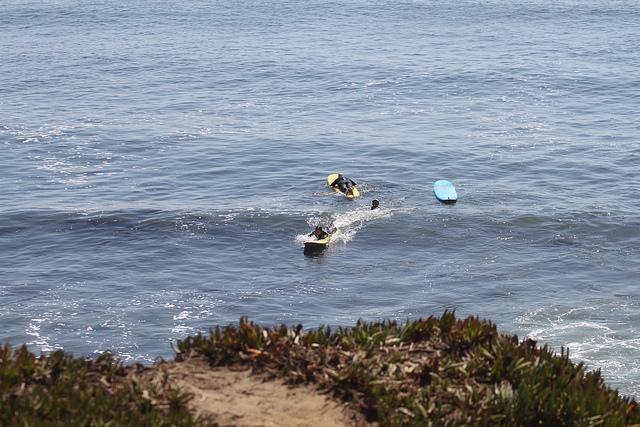How many people can be seen?
Give a very brief answer. 3. How many airplanes are in front of the control towers?
Give a very brief answer. 0. 